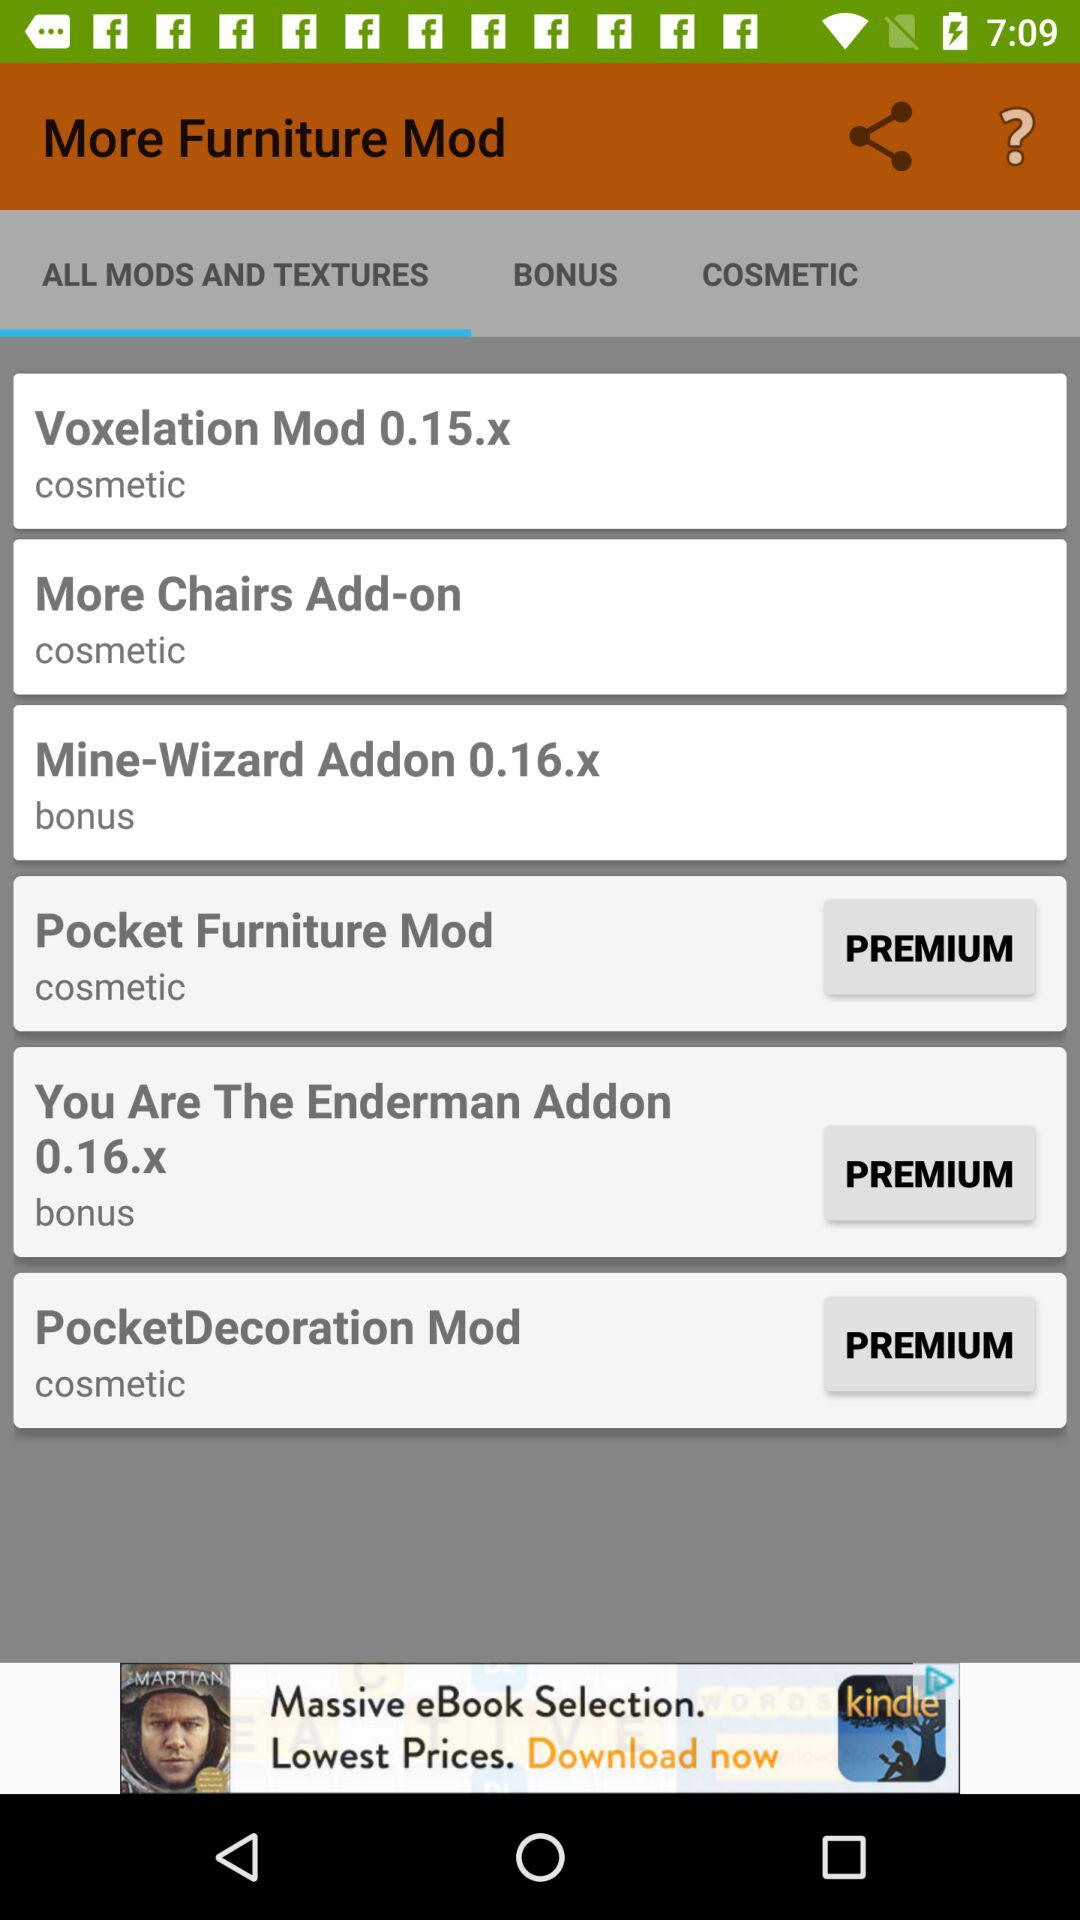How many bonus mods are there?
Answer the question using a single word or phrase. 2 